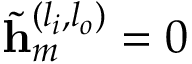<formula> <loc_0><loc_0><loc_500><loc_500>\tilde { h } _ { m } ^ { ( l _ { i } , l _ { o } ) } = 0</formula> 